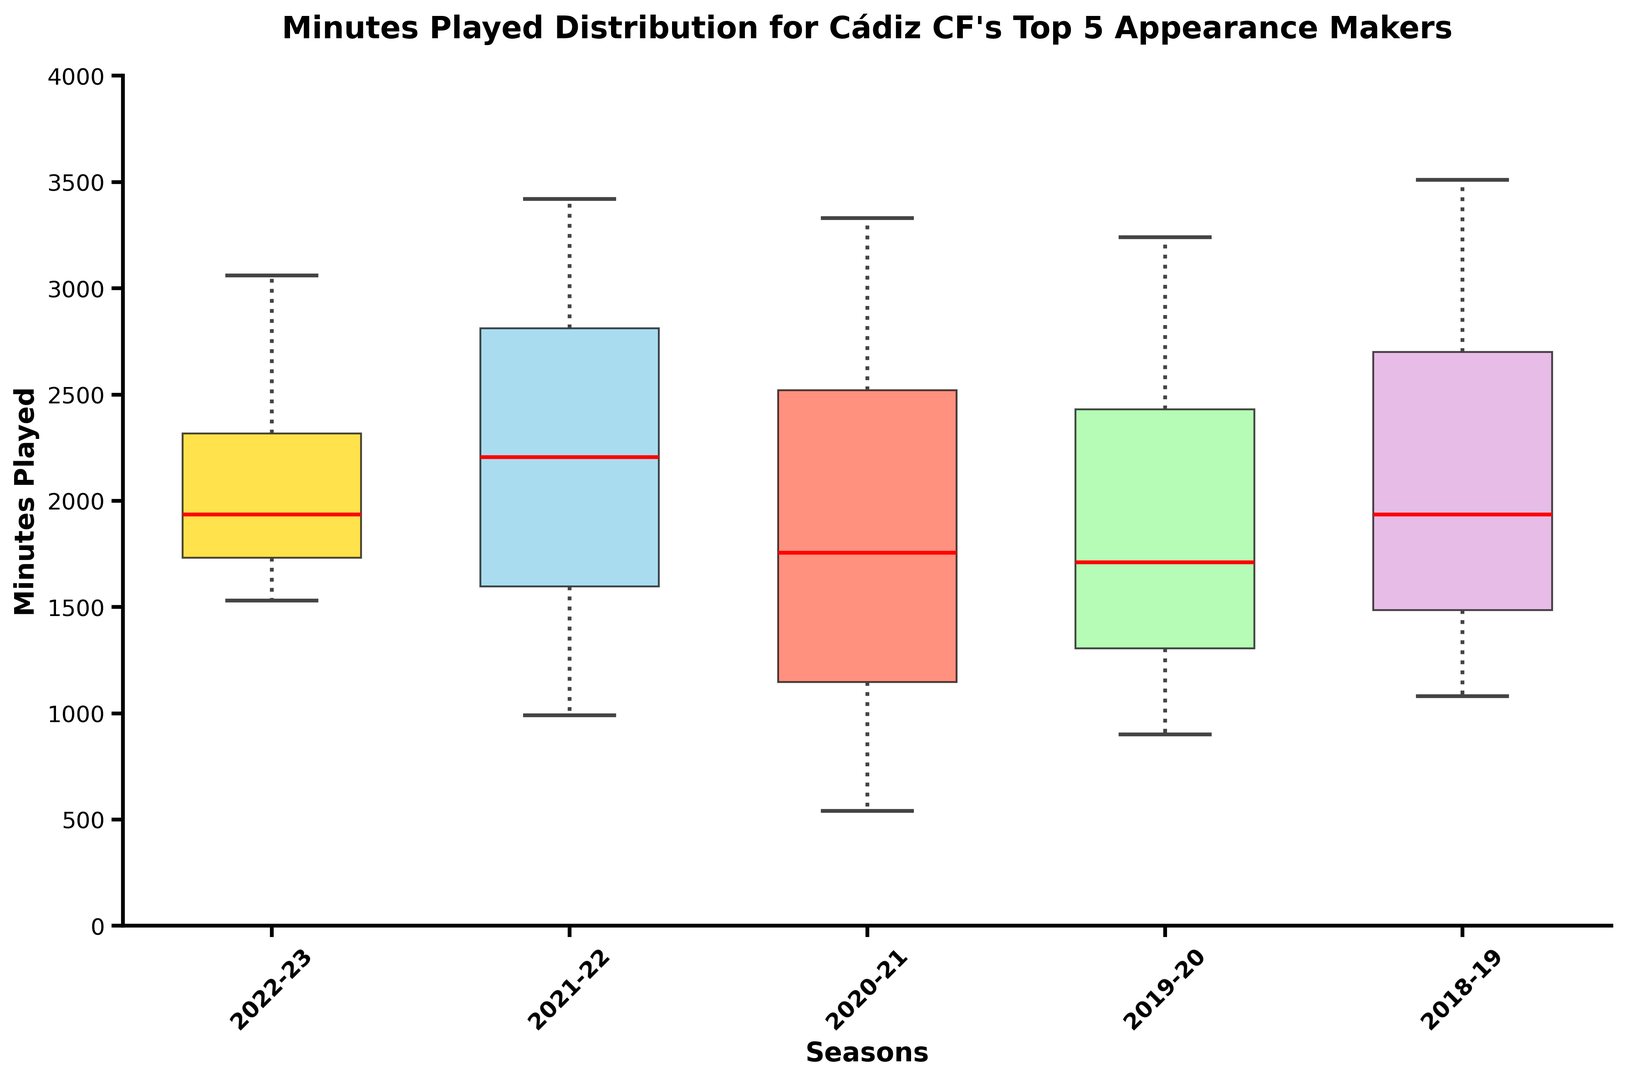Which season has the highest median number of minutes played? To find this, look for the season with the highest compared box line (red line). The 2021-22 box has the highest red line indicating it has the highest median.
Answer: 2021-22 What is the range of minutes played by the top 5 appearance makers in the 2018-19 season? The range is found by subtracting the lowest whisker point from the highest whisker point in the 2018-19 box. The 2018-19 season's highest whisker is at 3510 minutes and lowest is at 1080 minutes, so the range is 3510 - 1080 = 2430.
Answer: 2430 In which season is the interquartile range (IQR) of minutes played the smallest? The IQR is represented by the height of the box. The smallest IQR refers to the shortest height between the top and bottom of the box. The 2022-23 season has the smallest box height.
Answer: 2022-23 How does the upper quartile of the 2020-21 season compare to the 2022-23 season? The upper quartile (top of the box) needs to be compared. The top of the 2020-21 box is higher than the top of the 2022-23 box, indicating a higher upper quartile.
Answer: 2020-21 Which season shows the greatest spread (variance) in minutes played? The greatest spread can be determined by the length between the highest and lowest whiskers. The 2018-19 season has the longest distance between its whiskers.
Answer: 2018-19 What's the median value of minutes played in the 2019-20 season? The median value is represented by the red line in the box plot. For 2019-20, the red line is at 2520 minutes.
Answer: 2520 Which season had the lowest minimum minutes played by the top 5 appearance makers? The minimum is found at the bottom of the lowest whisker in each season's box plot. The lowest whisker is observed in the 2020-21 season, close to zero.
Answer: 2020-21 Compare the top quartile of minutes played between the 2021-22 and 2019-20 seasons. Which is higher? Compare the top ends of the boxes for the two seasons. The 2021-22 season has a higher top box end than the 2019-20 season.
Answer: 2021-22 